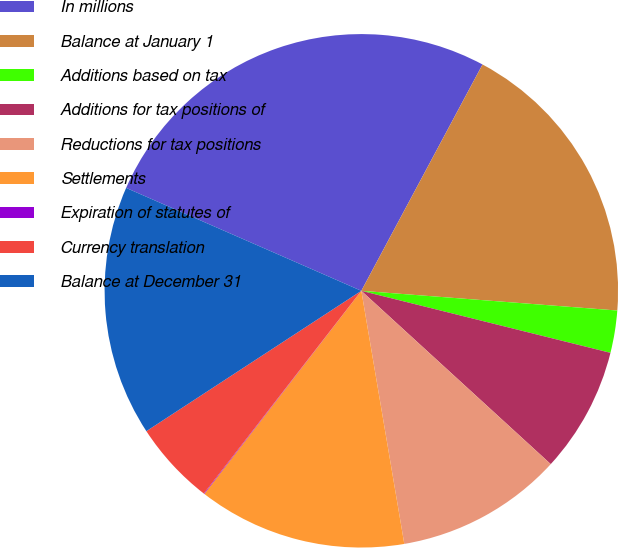Convert chart to OTSL. <chart><loc_0><loc_0><loc_500><loc_500><pie_chart><fcel>In millions<fcel>Balance at January 1<fcel>Additions based on tax<fcel>Additions for tax positions of<fcel>Reductions for tax positions<fcel>Settlements<fcel>Expiration of statutes of<fcel>Currency translation<fcel>Balance at December 31<nl><fcel>26.26%<fcel>18.4%<fcel>2.66%<fcel>7.91%<fcel>10.53%<fcel>13.15%<fcel>0.04%<fcel>5.28%<fcel>15.77%<nl></chart> 